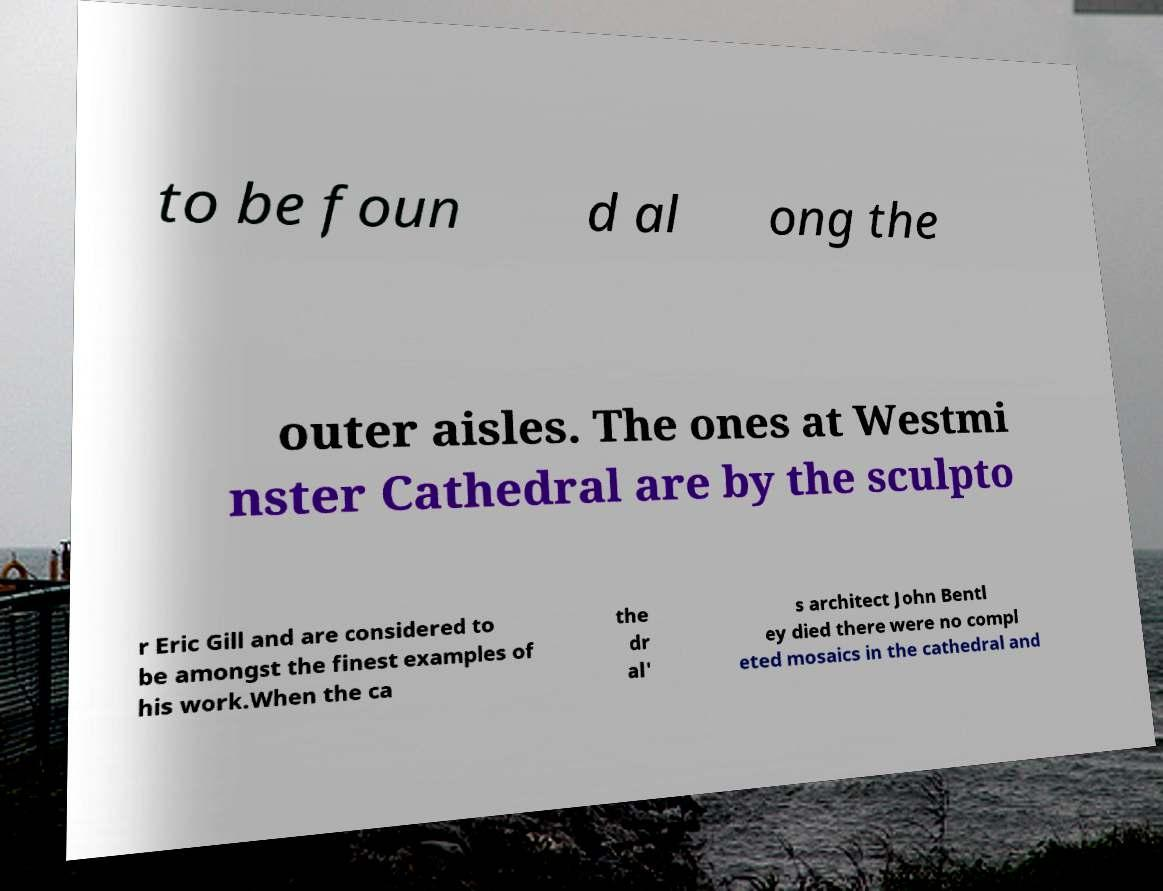Please read and relay the text visible in this image. What does it say? to be foun d al ong the outer aisles. The ones at Westmi nster Cathedral are by the sculpto r Eric Gill and are considered to be amongst the finest examples of his work.When the ca the dr al' s architect John Bentl ey died there were no compl eted mosaics in the cathedral and 